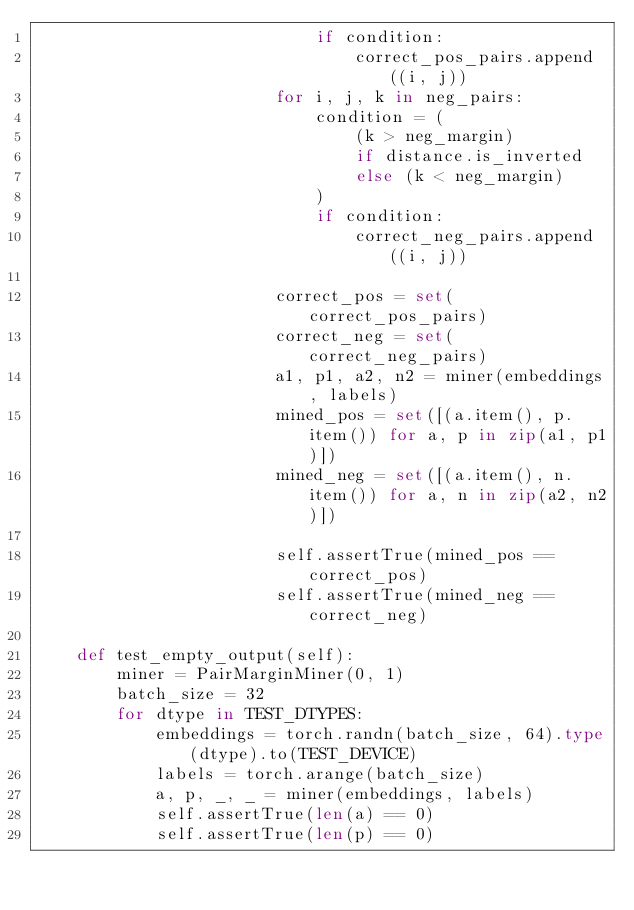<code> <loc_0><loc_0><loc_500><loc_500><_Python_>                            if condition:
                                correct_pos_pairs.append((i, j))
                        for i, j, k in neg_pairs:
                            condition = (
                                (k > neg_margin)
                                if distance.is_inverted
                                else (k < neg_margin)
                            )
                            if condition:
                                correct_neg_pairs.append((i, j))

                        correct_pos = set(correct_pos_pairs)
                        correct_neg = set(correct_neg_pairs)
                        a1, p1, a2, n2 = miner(embeddings, labels)
                        mined_pos = set([(a.item(), p.item()) for a, p in zip(a1, p1)])
                        mined_neg = set([(a.item(), n.item()) for a, n in zip(a2, n2)])

                        self.assertTrue(mined_pos == correct_pos)
                        self.assertTrue(mined_neg == correct_neg)

    def test_empty_output(self):
        miner = PairMarginMiner(0, 1)
        batch_size = 32
        for dtype in TEST_DTYPES:
            embeddings = torch.randn(batch_size, 64).type(dtype).to(TEST_DEVICE)
            labels = torch.arange(batch_size)
            a, p, _, _ = miner(embeddings, labels)
            self.assertTrue(len(a) == 0)
            self.assertTrue(len(p) == 0)
</code> 